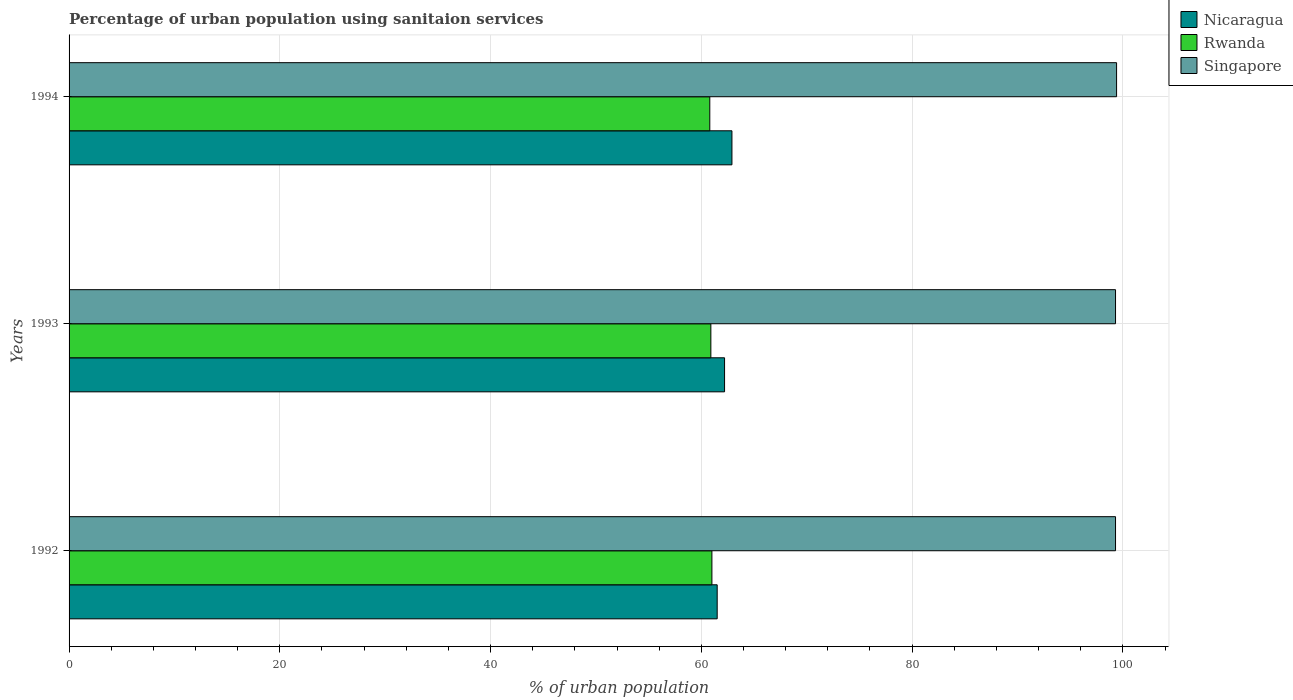How many different coloured bars are there?
Keep it short and to the point. 3. How many groups of bars are there?
Your response must be concise. 3. Are the number of bars per tick equal to the number of legend labels?
Offer a terse response. Yes. Are the number of bars on each tick of the Y-axis equal?
Ensure brevity in your answer.  Yes. How many bars are there on the 2nd tick from the top?
Ensure brevity in your answer.  3. How many bars are there on the 3rd tick from the bottom?
Provide a short and direct response. 3. In how many cases, is the number of bars for a given year not equal to the number of legend labels?
Provide a short and direct response. 0. What is the percentage of urban population using sanitaion services in Singapore in 1993?
Make the answer very short. 99.3. Across all years, what is the maximum percentage of urban population using sanitaion services in Singapore?
Your answer should be compact. 99.4. Across all years, what is the minimum percentage of urban population using sanitaion services in Singapore?
Make the answer very short. 99.3. In which year was the percentage of urban population using sanitaion services in Singapore maximum?
Provide a short and direct response. 1994. In which year was the percentage of urban population using sanitaion services in Nicaragua minimum?
Give a very brief answer. 1992. What is the total percentage of urban population using sanitaion services in Rwanda in the graph?
Offer a very short reply. 182.7. What is the difference between the percentage of urban population using sanitaion services in Nicaragua in 1993 and the percentage of urban population using sanitaion services in Singapore in 1994?
Make the answer very short. -37.2. What is the average percentage of urban population using sanitaion services in Singapore per year?
Offer a very short reply. 99.33. In the year 1993, what is the difference between the percentage of urban population using sanitaion services in Singapore and percentage of urban population using sanitaion services in Rwanda?
Your response must be concise. 38.4. In how many years, is the percentage of urban population using sanitaion services in Singapore greater than 80 %?
Offer a terse response. 3. What is the ratio of the percentage of urban population using sanitaion services in Nicaragua in 1992 to that in 1994?
Offer a very short reply. 0.98. Is the percentage of urban population using sanitaion services in Singapore in 1993 less than that in 1994?
Give a very brief answer. Yes. Is the difference between the percentage of urban population using sanitaion services in Singapore in 1993 and 1994 greater than the difference between the percentage of urban population using sanitaion services in Rwanda in 1993 and 1994?
Provide a short and direct response. No. What is the difference between the highest and the second highest percentage of urban population using sanitaion services in Singapore?
Offer a terse response. 0.1. What is the difference between the highest and the lowest percentage of urban population using sanitaion services in Singapore?
Keep it short and to the point. 0.1. In how many years, is the percentage of urban population using sanitaion services in Singapore greater than the average percentage of urban population using sanitaion services in Singapore taken over all years?
Offer a very short reply. 1. What does the 2nd bar from the top in 1992 represents?
Offer a terse response. Rwanda. What does the 1st bar from the bottom in 1993 represents?
Offer a very short reply. Nicaragua. Is it the case that in every year, the sum of the percentage of urban population using sanitaion services in Rwanda and percentage of urban population using sanitaion services in Singapore is greater than the percentage of urban population using sanitaion services in Nicaragua?
Give a very brief answer. Yes. How many years are there in the graph?
Your response must be concise. 3. What is the difference between two consecutive major ticks on the X-axis?
Make the answer very short. 20. Are the values on the major ticks of X-axis written in scientific E-notation?
Make the answer very short. No. Where does the legend appear in the graph?
Provide a short and direct response. Top right. How many legend labels are there?
Make the answer very short. 3. How are the legend labels stacked?
Offer a very short reply. Vertical. What is the title of the graph?
Provide a short and direct response. Percentage of urban population using sanitaion services. Does "Peru" appear as one of the legend labels in the graph?
Ensure brevity in your answer.  No. What is the label or title of the X-axis?
Your response must be concise. % of urban population. What is the % of urban population of Nicaragua in 1992?
Offer a very short reply. 61.5. What is the % of urban population of Rwanda in 1992?
Make the answer very short. 61. What is the % of urban population of Singapore in 1992?
Provide a succinct answer. 99.3. What is the % of urban population of Nicaragua in 1993?
Provide a succinct answer. 62.2. What is the % of urban population of Rwanda in 1993?
Offer a very short reply. 60.9. What is the % of urban population of Singapore in 1993?
Offer a very short reply. 99.3. What is the % of urban population of Nicaragua in 1994?
Ensure brevity in your answer.  62.9. What is the % of urban population in Rwanda in 1994?
Your answer should be very brief. 60.8. What is the % of urban population of Singapore in 1994?
Make the answer very short. 99.4. Across all years, what is the maximum % of urban population of Nicaragua?
Your answer should be very brief. 62.9. Across all years, what is the maximum % of urban population in Rwanda?
Make the answer very short. 61. Across all years, what is the maximum % of urban population of Singapore?
Offer a very short reply. 99.4. Across all years, what is the minimum % of urban population of Nicaragua?
Provide a succinct answer. 61.5. Across all years, what is the minimum % of urban population in Rwanda?
Make the answer very short. 60.8. Across all years, what is the minimum % of urban population of Singapore?
Your response must be concise. 99.3. What is the total % of urban population of Nicaragua in the graph?
Keep it short and to the point. 186.6. What is the total % of urban population of Rwanda in the graph?
Your answer should be compact. 182.7. What is the total % of urban population in Singapore in the graph?
Ensure brevity in your answer.  298. What is the difference between the % of urban population in Singapore in 1992 and that in 1993?
Ensure brevity in your answer.  0. What is the difference between the % of urban population of Singapore in 1992 and that in 1994?
Offer a terse response. -0.1. What is the difference between the % of urban population of Nicaragua in 1992 and the % of urban population of Singapore in 1993?
Keep it short and to the point. -37.8. What is the difference between the % of urban population in Rwanda in 1992 and the % of urban population in Singapore in 1993?
Provide a succinct answer. -38.3. What is the difference between the % of urban population in Nicaragua in 1992 and the % of urban population in Singapore in 1994?
Give a very brief answer. -37.9. What is the difference between the % of urban population of Rwanda in 1992 and the % of urban population of Singapore in 1994?
Keep it short and to the point. -38.4. What is the difference between the % of urban population of Nicaragua in 1993 and the % of urban population of Singapore in 1994?
Provide a short and direct response. -37.2. What is the difference between the % of urban population in Rwanda in 1993 and the % of urban population in Singapore in 1994?
Provide a succinct answer. -38.5. What is the average % of urban population in Nicaragua per year?
Give a very brief answer. 62.2. What is the average % of urban population of Rwanda per year?
Keep it short and to the point. 60.9. What is the average % of urban population in Singapore per year?
Provide a short and direct response. 99.33. In the year 1992, what is the difference between the % of urban population of Nicaragua and % of urban population of Rwanda?
Provide a succinct answer. 0.5. In the year 1992, what is the difference between the % of urban population of Nicaragua and % of urban population of Singapore?
Provide a short and direct response. -37.8. In the year 1992, what is the difference between the % of urban population of Rwanda and % of urban population of Singapore?
Make the answer very short. -38.3. In the year 1993, what is the difference between the % of urban population in Nicaragua and % of urban population in Singapore?
Provide a short and direct response. -37.1. In the year 1993, what is the difference between the % of urban population in Rwanda and % of urban population in Singapore?
Your answer should be very brief. -38.4. In the year 1994, what is the difference between the % of urban population of Nicaragua and % of urban population of Rwanda?
Offer a terse response. 2.1. In the year 1994, what is the difference between the % of urban population of Nicaragua and % of urban population of Singapore?
Keep it short and to the point. -36.5. In the year 1994, what is the difference between the % of urban population of Rwanda and % of urban population of Singapore?
Your answer should be compact. -38.6. What is the ratio of the % of urban population in Nicaragua in 1992 to that in 1993?
Keep it short and to the point. 0.99. What is the ratio of the % of urban population of Nicaragua in 1992 to that in 1994?
Offer a very short reply. 0.98. What is the ratio of the % of urban population in Nicaragua in 1993 to that in 1994?
Offer a very short reply. 0.99. What is the ratio of the % of urban population in Rwanda in 1993 to that in 1994?
Provide a short and direct response. 1. What is the ratio of the % of urban population in Singapore in 1993 to that in 1994?
Offer a terse response. 1. What is the difference between the highest and the second highest % of urban population of Rwanda?
Give a very brief answer. 0.1. What is the difference between the highest and the second highest % of urban population in Singapore?
Your answer should be compact. 0.1. What is the difference between the highest and the lowest % of urban population of Nicaragua?
Your response must be concise. 1.4. What is the difference between the highest and the lowest % of urban population in Rwanda?
Keep it short and to the point. 0.2. What is the difference between the highest and the lowest % of urban population in Singapore?
Keep it short and to the point. 0.1. 